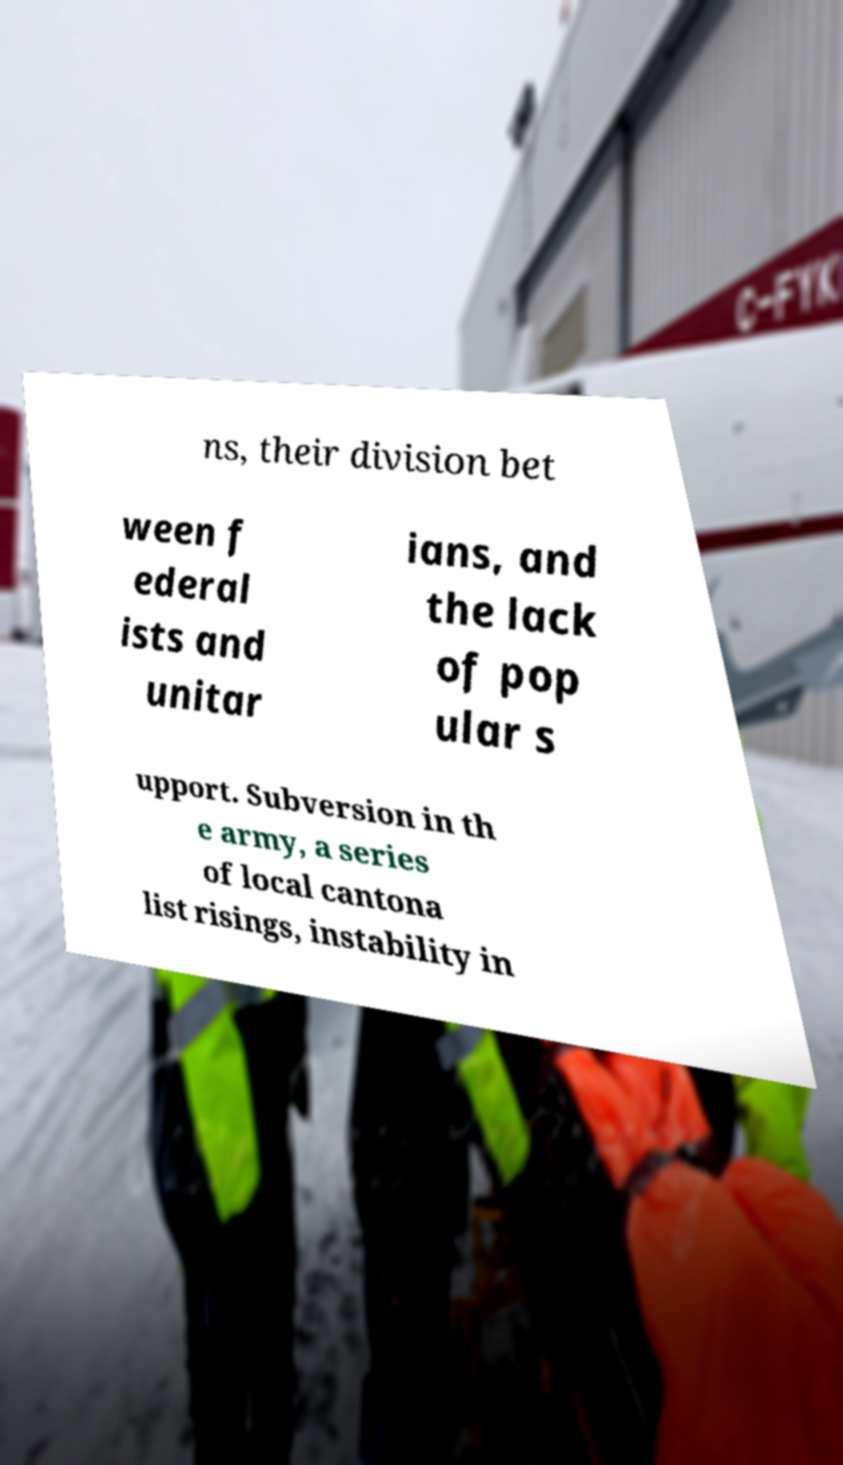What messages or text are displayed in this image? I need them in a readable, typed format. ns, their division bet ween f ederal ists and unitar ians, and the lack of pop ular s upport. Subversion in th e army, a series of local cantona list risings, instability in 